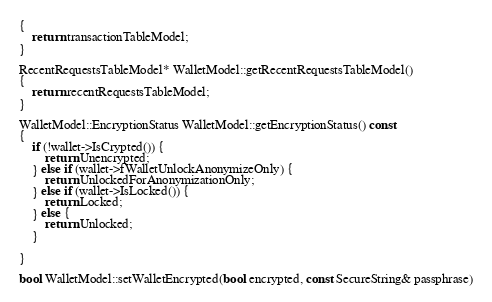<code> <loc_0><loc_0><loc_500><loc_500><_C++_>{
    return transactionTableModel;
}

RecentRequestsTableModel* WalletModel::getRecentRequestsTableModel()
{
    return recentRequestsTableModel;
}

WalletModel::EncryptionStatus WalletModel::getEncryptionStatus() const
{
    if (!wallet->IsCrypted()) {
        return Unencrypted;
    } else if (wallet->fWalletUnlockAnonymizeOnly) {
        return UnlockedForAnonymizationOnly;
    } else if (wallet->IsLocked()) {
        return Locked;
    } else {
        return Unlocked;
    }

}

bool WalletModel::setWalletEncrypted(bool encrypted, const SecureString& passphrase)</code> 